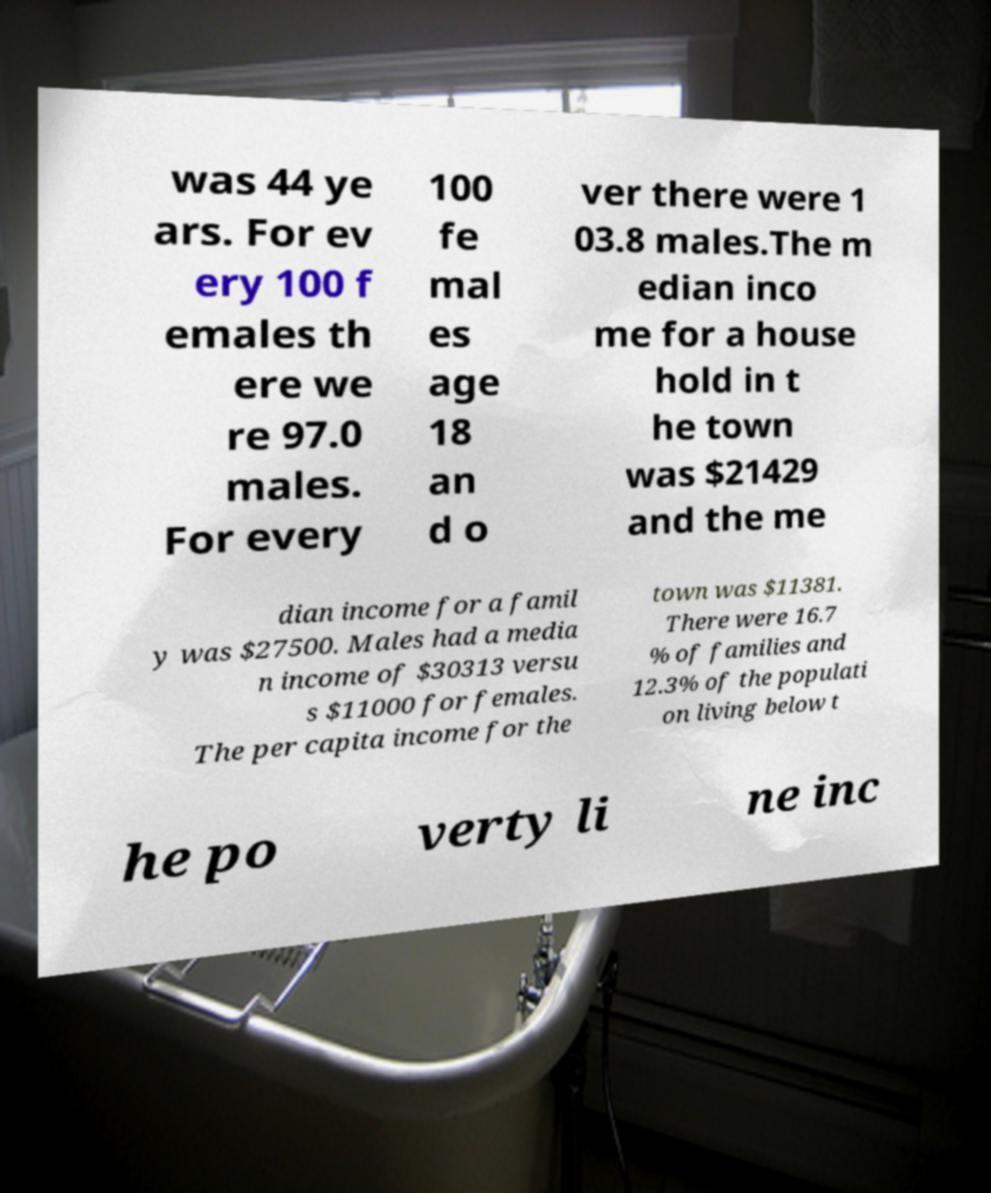For documentation purposes, I need the text within this image transcribed. Could you provide that? was 44 ye ars. For ev ery 100 f emales th ere we re 97.0 males. For every 100 fe mal es age 18 an d o ver there were 1 03.8 males.The m edian inco me for a house hold in t he town was $21429 and the me dian income for a famil y was $27500. Males had a media n income of $30313 versu s $11000 for females. The per capita income for the town was $11381. There were 16.7 % of families and 12.3% of the populati on living below t he po verty li ne inc 